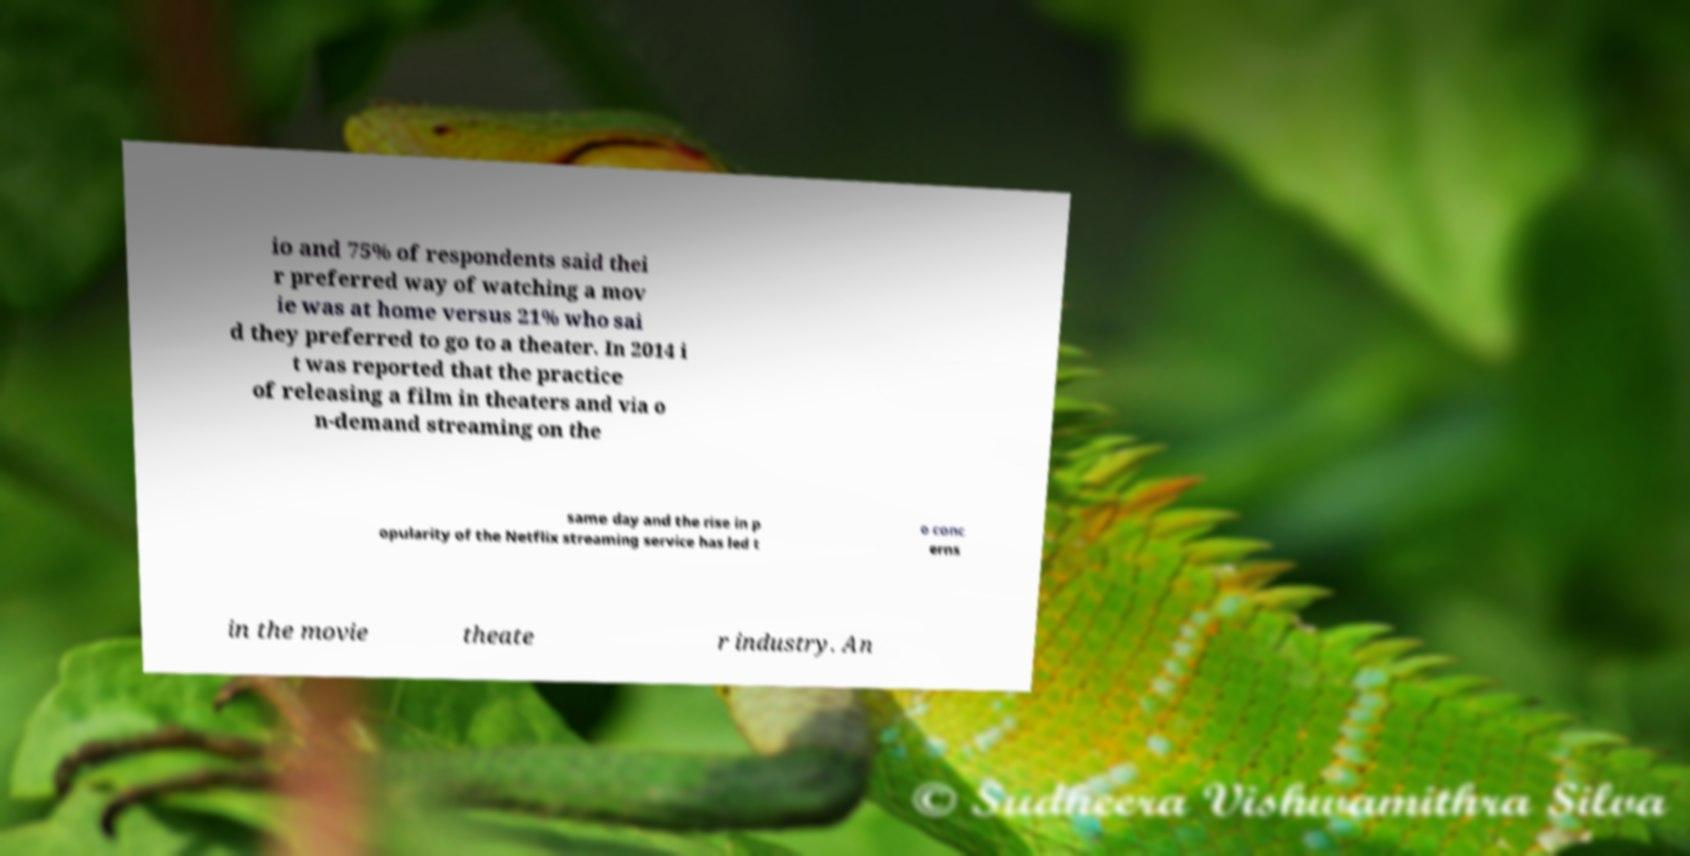Can you read and provide the text displayed in the image?This photo seems to have some interesting text. Can you extract and type it out for me? io and 75% of respondents said thei r preferred way of watching a mov ie was at home versus 21% who sai d they preferred to go to a theater. In 2014 i t was reported that the practice of releasing a film in theaters and via o n-demand streaming on the same day and the rise in p opularity of the Netflix streaming service has led t o conc erns in the movie theate r industry. An 